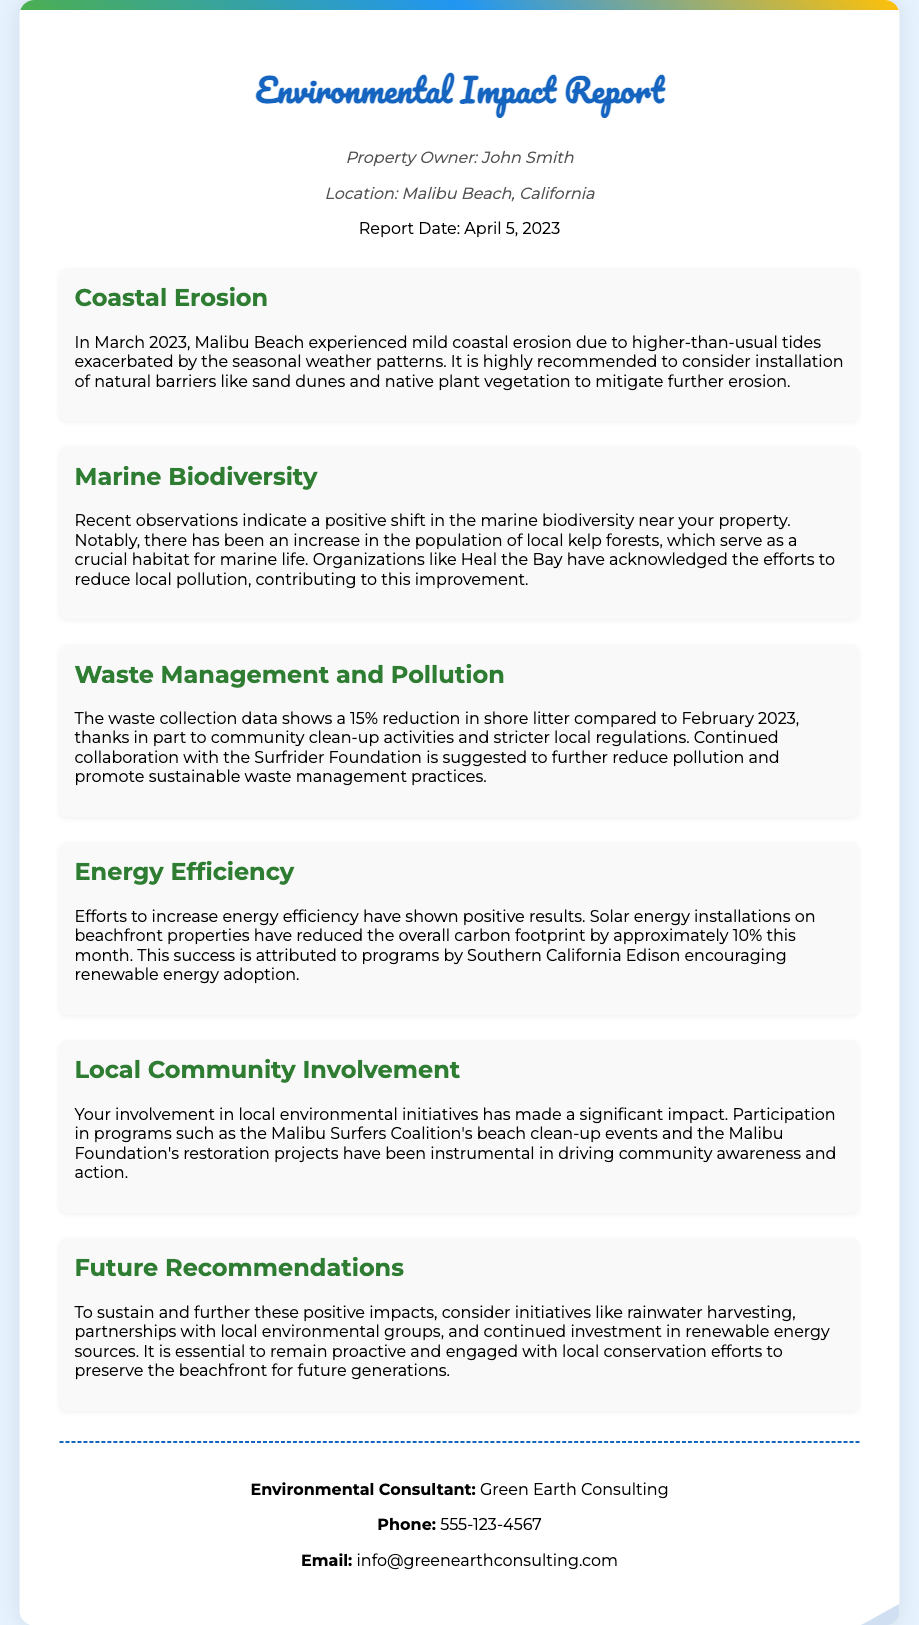What is the property owner's name? The property owner's name is mentioned in the document as John Smith.
Answer: John Smith What is the location of the property? The location of the property is specified in the report as Malibu Beach, California.
Answer: Malibu Beach, California What was the percentage reduction in shore litter? The document states that there has been a 15% reduction in shore litter compared to February 2023.
Answer: 15% What environmental initiative has the property owner participated in? The report mentions participation in the Malibu Surfers Coalition's beach clean-up events as a local environmental initiative.
Answer: Malibu Surfers Coalition's beach clean-up events What is one of the recommendations for future actions? The future recommendations include initiatives like rainwater harvesting to sustain positive impacts.
Answer: Rainwater harvesting Which organization is suggested for collaboration to reduce pollution? The document suggests continued collaboration with the Surfrider Foundation for pollution reduction.
Answer: Surfrider Foundation What positive trend is observed in marine biodiversity? The report indicates an increase in the population of local kelp forests as a positive trend in marine biodiversity.
Answer: Increase in local kelp forests When was the report date? The report date is mentioned in the document as April 5, 2023.
Answer: April 5, 2023 